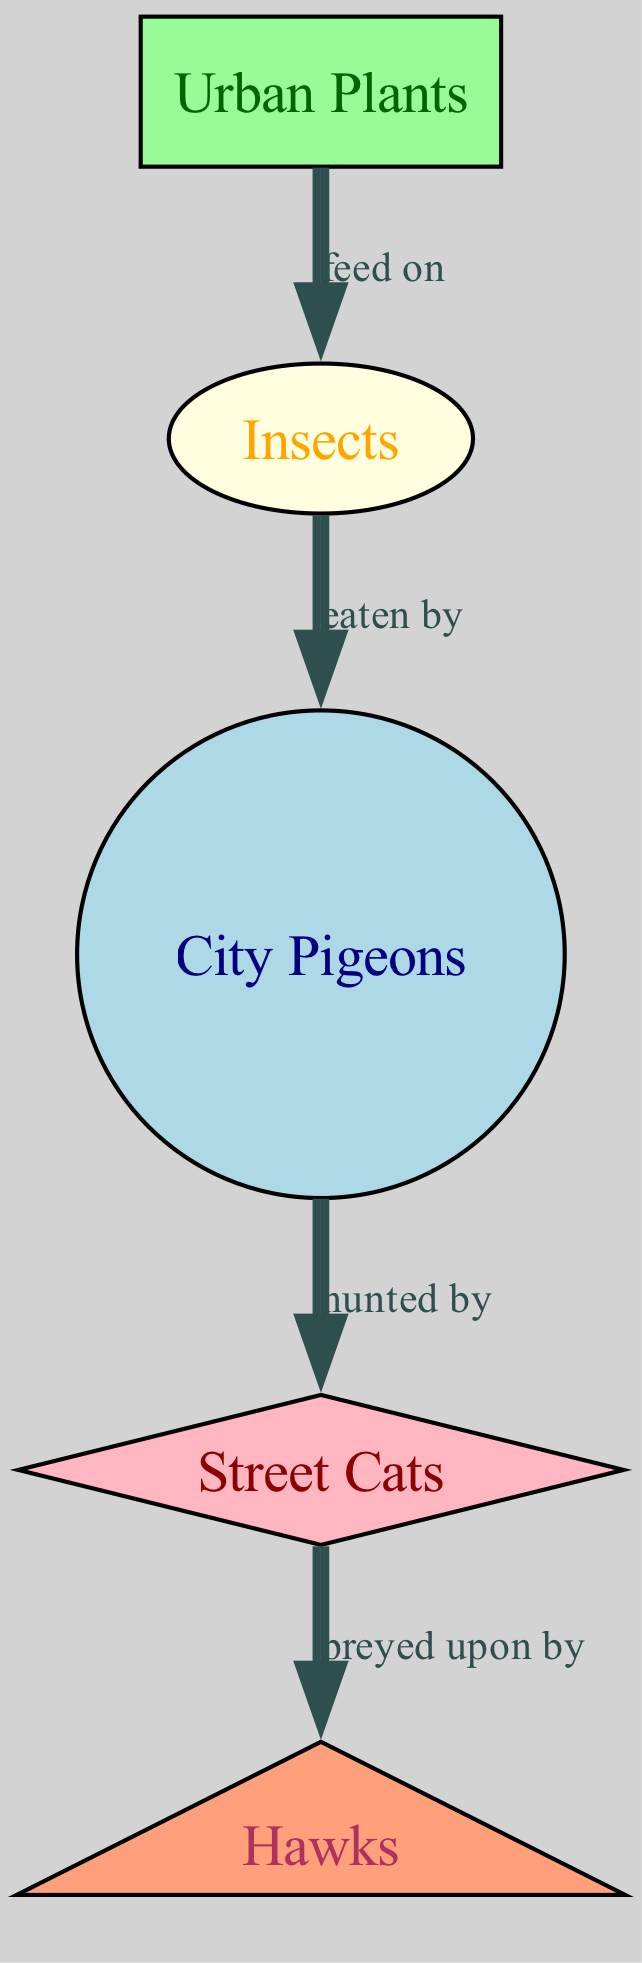What's the first trophic level in the diagram? The first trophic level consists of primary producers, which in this diagram are represented by "Urban Plants."
Answer: Urban Plants How many nodes are in the food chain? Count the nodes in the diagram: Urban Plants, Insects, City Pigeons, Street Cats, and Hawks. That's a total of 5 nodes.
Answer: 5 Which organism is described as being eaten by city pigeons? The edge from "Insects" to "City Pigeons" indicates that insects are the organisms eaten by city pigeons.
Answer: Insects What type of relationship exists between street cats and hawks? The relationship between Street Cats and Hawks is indicated by the edge labeled "preyed upon by," illustrating a predator-prey dynamic.
Answer: preyed upon by If urban plants decrease in number, which organism would be most directly affected? Urban Plants are the primary producers that insects rely on for food. If the number of urban plants decreases, insects would be directly affected.
Answer: Insects Who is at the highest trophic level in this urban food chain? Hawks are at the highest trophic level in this food chain as they are the top predators, indicated by the lack of predators above them.
Answer: Hawks What is the feeding relationship of city pigeons within the chain? City Pigeons are consumed by street cats, establishing them as a prey species in this urban food web.
Answer: hunted by How many edges are present in the food chain diagram? Count the edges: Urban Plants to Insects, Insects to City Pigeons, City Pigeons to Street Cats, and Street Cats to Hawks, totaling 4 edges.
Answer: 4 What color represents urban plants in the diagram? The node for Urban Plants is filled with pale green, which visually distinguishes it from other organisms in the food chain.
Answer: pale green 